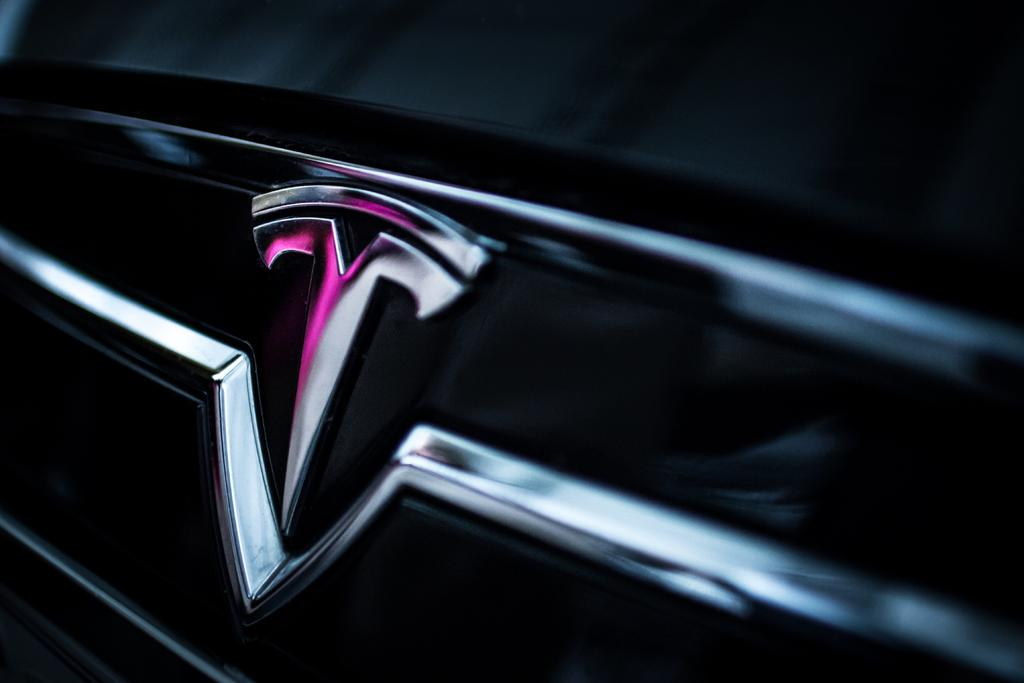What color is the car in the image? The car is black. Can you identify any specific features of the car? Yes, there is a visible car logo. How many clams are sitting on the hood of the car in the image? There are no clams present in the image; it features a black car with a visible car logo. What type of straw is used to decorate the car in the image? There is no straw present in the image; it features a black car with a visible car logo. 